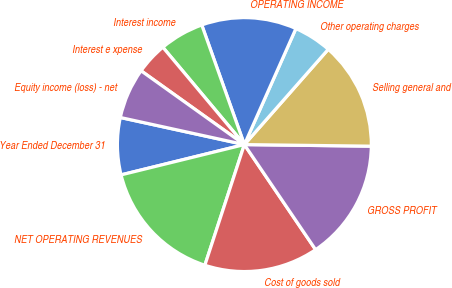Convert chart. <chart><loc_0><loc_0><loc_500><loc_500><pie_chart><fcel>Year Ended December 31<fcel>NET OPERATING REVENUES<fcel>Cost of goods sold<fcel>GROSS PROFIT<fcel>Selling general and<fcel>Other operating charges<fcel>OPERATING INCOME<fcel>Interest income<fcel>Interest e xpense<fcel>Equity income (loss) - net<nl><fcel>7.26%<fcel>16.13%<fcel>14.52%<fcel>15.32%<fcel>13.71%<fcel>4.84%<fcel>12.1%<fcel>5.65%<fcel>4.03%<fcel>6.45%<nl></chart> 